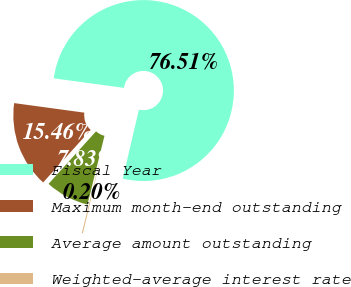Convert chart to OTSL. <chart><loc_0><loc_0><loc_500><loc_500><pie_chart><fcel>Fiscal Year<fcel>Maximum month-end outstanding<fcel>Average amount outstanding<fcel>Weighted-average interest rate<nl><fcel>76.5%<fcel>15.46%<fcel>7.83%<fcel>0.2%<nl></chart> 